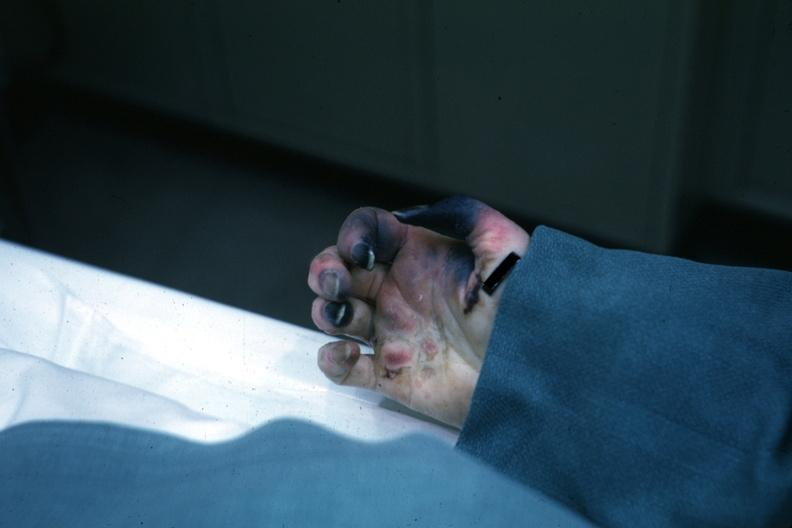what does this image show?
Answer the question using a single word or phrase. Obvious gangrenous necrosis child with congenital heart disease post op exact cause not know shock vs emboli 